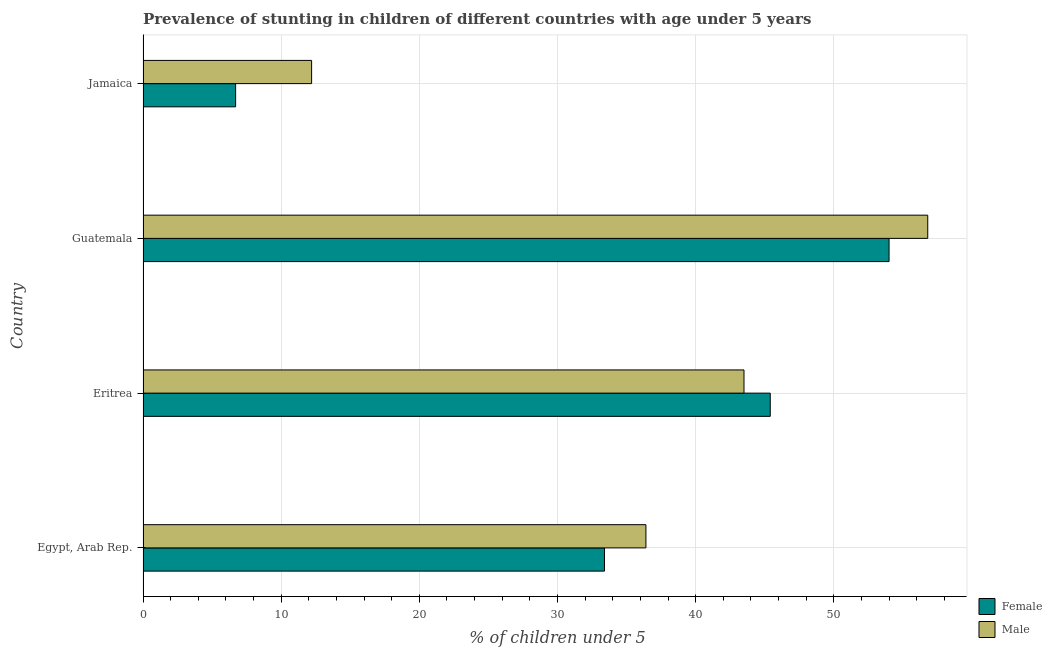How many different coloured bars are there?
Offer a terse response. 2. How many groups of bars are there?
Offer a very short reply. 4. Are the number of bars per tick equal to the number of legend labels?
Provide a short and direct response. Yes. How many bars are there on the 4th tick from the top?
Keep it short and to the point. 2. How many bars are there on the 3rd tick from the bottom?
Provide a succinct answer. 2. What is the label of the 2nd group of bars from the top?
Provide a succinct answer. Guatemala. What is the percentage of stunted female children in Guatemala?
Make the answer very short. 54. Across all countries, what is the maximum percentage of stunted female children?
Your answer should be compact. 54. Across all countries, what is the minimum percentage of stunted female children?
Make the answer very short. 6.7. In which country was the percentage of stunted female children maximum?
Offer a terse response. Guatemala. In which country was the percentage of stunted male children minimum?
Your response must be concise. Jamaica. What is the total percentage of stunted male children in the graph?
Offer a very short reply. 148.9. What is the difference between the percentage of stunted female children in Guatemala and that in Jamaica?
Your response must be concise. 47.3. What is the average percentage of stunted male children per country?
Provide a short and direct response. 37.23. What is the ratio of the percentage of stunted female children in Egypt, Arab Rep. to that in Guatemala?
Give a very brief answer. 0.62. What is the difference between the highest and the second highest percentage of stunted male children?
Keep it short and to the point. 13.3. What is the difference between the highest and the lowest percentage of stunted female children?
Your response must be concise. 47.3. In how many countries, is the percentage of stunted female children greater than the average percentage of stunted female children taken over all countries?
Keep it short and to the point. 2. What does the 2nd bar from the bottom in Guatemala represents?
Make the answer very short. Male. How many bars are there?
Your response must be concise. 8. Are all the bars in the graph horizontal?
Your answer should be compact. Yes. Does the graph contain grids?
Your answer should be compact. Yes. How many legend labels are there?
Your answer should be compact. 2. How are the legend labels stacked?
Your response must be concise. Vertical. What is the title of the graph?
Your response must be concise. Prevalence of stunting in children of different countries with age under 5 years. What is the label or title of the X-axis?
Your response must be concise.  % of children under 5. What is the  % of children under 5 of Female in Egypt, Arab Rep.?
Make the answer very short. 33.4. What is the  % of children under 5 of Male in Egypt, Arab Rep.?
Offer a terse response. 36.4. What is the  % of children under 5 of Female in Eritrea?
Give a very brief answer. 45.4. What is the  % of children under 5 in Male in Eritrea?
Your answer should be very brief. 43.5. What is the  % of children under 5 in Male in Guatemala?
Offer a very short reply. 56.8. What is the  % of children under 5 of Female in Jamaica?
Give a very brief answer. 6.7. What is the  % of children under 5 of Male in Jamaica?
Give a very brief answer. 12.2. Across all countries, what is the maximum  % of children under 5 in Female?
Provide a succinct answer. 54. Across all countries, what is the maximum  % of children under 5 in Male?
Offer a terse response. 56.8. Across all countries, what is the minimum  % of children under 5 of Female?
Give a very brief answer. 6.7. Across all countries, what is the minimum  % of children under 5 of Male?
Your answer should be compact. 12.2. What is the total  % of children under 5 of Female in the graph?
Give a very brief answer. 139.5. What is the total  % of children under 5 in Male in the graph?
Your answer should be compact. 148.9. What is the difference between the  % of children under 5 of Female in Egypt, Arab Rep. and that in Eritrea?
Offer a very short reply. -12. What is the difference between the  % of children under 5 of Male in Egypt, Arab Rep. and that in Eritrea?
Offer a very short reply. -7.1. What is the difference between the  % of children under 5 in Female in Egypt, Arab Rep. and that in Guatemala?
Provide a short and direct response. -20.6. What is the difference between the  % of children under 5 in Male in Egypt, Arab Rep. and that in Guatemala?
Your answer should be very brief. -20.4. What is the difference between the  % of children under 5 in Female in Egypt, Arab Rep. and that in Jamaica?
Make the answer very short. 26.7. What is the difference between the  % of children under 5 in Male in Egypt, Arab Rep. and that in Jamaica?
Give a very brief answer. 24.2. What is the difference between the  % of children under 5 of Female in Eritrea and that in Guatemala?
Provide a succinct answer. -8.6. What is the difference between the  % of children under 5 in Female in Eritrea and that in Jamaica?
Provide a succinct answer. 38.7. What is the difference between the  % of children under 5 in Male in Eritrea and that in Jamaica?
Offer a very short reply. 31.3. What is the difference between the  % of children under 5 in Female in Guatemala and that in Jamaica?
Ensure brevity in your answer.  47.3. What is the difference between the  % of children under 5 of Male in Guatemala and that in Jamaica?
Ensure brevity in your answer.  44.6. What is the difference between the  % of children under 5 of Female in Egypt, Arab Rep. and the  % of children under 5 of Male in Eritrea?
Provide a succinct answer. -10.1. What is the difference between the  % of children under 5 in Female in Egypt, Arab Rep. and the  % of children under 5 in Male in Guatemala?
Your answer should be compact. -23.4. What is the difference between the  % of children under 5 of Female in Egypt, Arab Rep. and the  % of children under 5 of Male in Jamaica?
Provide a succinct answer. 21.2. What is the difference between the  % of children under 5 of Female in Eritrea and the  % of children under 5 of Male in Jamaica?
Ensure brevity in your answer.  33.2. What is the difference between the  % of children under 5 in Female in Guatemala and the  % of children under 5 in Male in Jamaica?
Your response must be concise. 41.8. What is the average  % of children under 5 of Female per country?
Offer a terse response. 34.88. What is the average  % of children under 5 of Male per country?
Your answer should be very brief. 37.23. What is the difference between the  % of children under 5 in Female and  % of children under 5 in Male in Egypt, Arab Rep.?
Offer a terse response. -3. What is the difference between the  % of children under 5 in Female and  % of children under 5 in Male in Guatemala?
Provide a short and direct response. -2.8. What is the difference between the  % of children under 5 of Female and  % of children under 5 of Male in Jamaica?
Offer a terse response. -5.5. What is the ratio of the  % of children under 5 of Female in Egypt, Arab Rep. to that in Eritrea?
Provide a succinct answer. 0.74. What is the ratio of the  % of children under 5 in Male in Egypt, Arab Rep. to that in Eritrea?
Your response must be concise. 0.84. What is the ratio of the  % of children under 5 in Female in Egypt, Arab Rep. to that in Guatemala?
Ensure brevity in your answer.  0.62. What is the ratio of the  % of children under 5 of Male in Egypt, Arab Rep. to that in Guatemala?
Offer a very short reply. 0.64. What is the ratio of the  % of children under 5 of Female in Egypt, Arab Rep. to that in Jamaica?
Ensure brevity in your answer.  4.99. What is the ratio of the  % of children under 5 of Male in Egypt, Arab Rep. to that in Jamaica?
Provide a short and direct response. 2.98. What is the ratio of the  % of children under 5 of Female in Eritrea to that in Guatemala?
Offer a terse response. 0.84. What is the ratio of the  % of children under 5 of Male in Eritrea to that in Guatemala?
Your response must be concise. 0.77. What is the ratio of the  % of children under 5 in Female in Eritrea to that in Jamaica?
Make the answer very short. 6.78. What is the ratio of the  % of children under 5 in Male in Eritrea to that in Jamaica?
Provide a succinct answer. 3.57. What is the ratio of the  % of children under 5 of Female in Guatemala to that in Jamaica?
Offer a terse response. 8.06. What is the ratio of the  % of children under 5 of Male in Guatemala to that in Jamaica?
Your answer should be very brief. 4.66. What is the difference between the highest and the second highest  % of children under 5 of Female?
Make the answer very short. 8.6. What is the difference between the highest and the second highest  % of children under 5 of Male?
Your response must be concise. 13.3. What is the difference between the highest and the lowest  % of children under 5 in Female?
Your response must be concise. 47.3. What is the difference between the highest and the lowest  % of children under 5 of Male?
Offer a terse response. 44.6. 